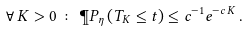<formula> <loc_0><loc_0><loc_500><loc_500>\forall \, K > 0 \, \colon \, \P P _ { \eta } \left ( T _ { K } \leq t \right ) \leq c ^ { - 1 } e ^ { - c \, K } \, .</formula> 